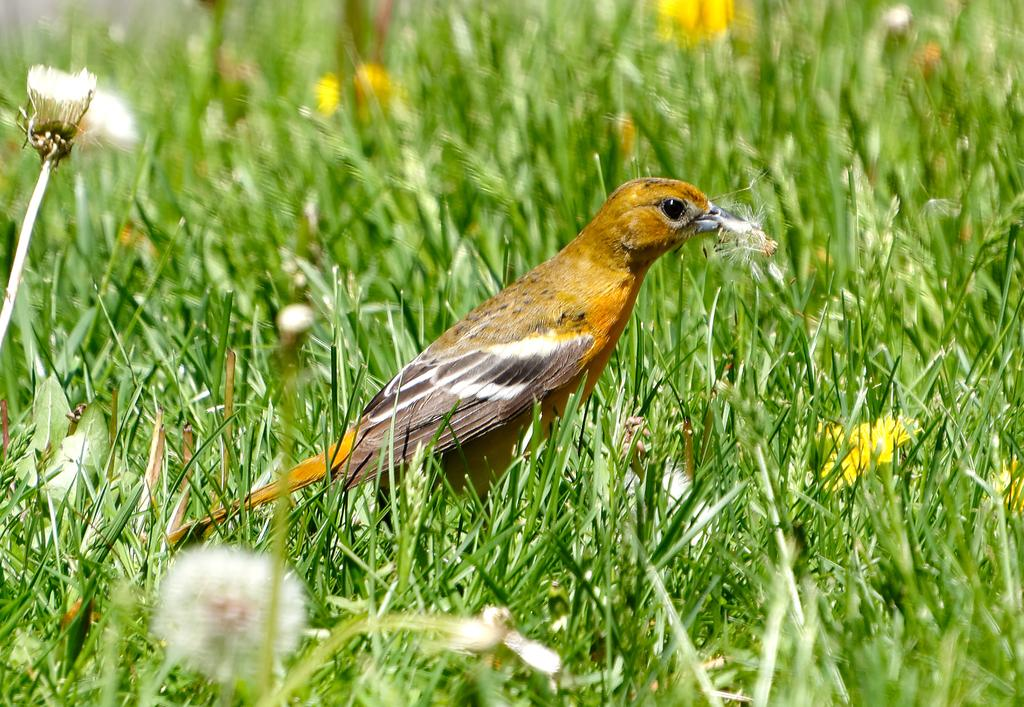What type of animal is in the image? There is a bird in the image. Where is the bird located? The bird is on the grass. What other elements can be seen at the bottom of the image? There are flowers visible at the bottom of the image. What type of fork is the bird using to eat the lead in the image? There is no fork, lead, or any indication of the bird eating in the image. 